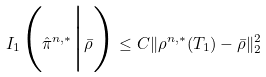Convert formula to latex. <formula><loc_0><loc_0><loc_500><loc_500>I _ { 1 } \Big ( \hat { \pi } ^ { n , * } \Big | \bar { \rho } \Big ) \leq C \| \rho ^ { n , * } ( T _ { 1 } ) - \bar { \rho } \| _ { 2 } ^ { 2 }</formula> 